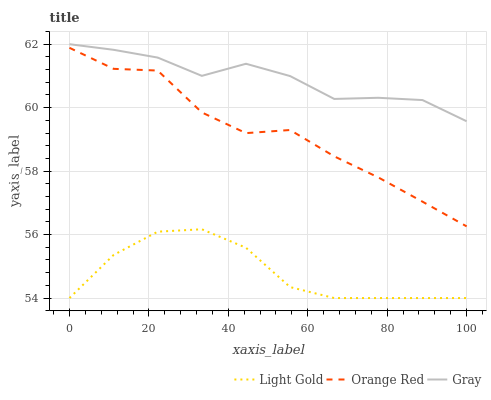Does Light Gold have the minimum area under the curve?
Answer yes or no. Yes. Does Gray have the maximum area under the curve?
Answer yes or no. Yes. Does Orange Red have the minimum area under the curve?
Answer yes or no. No. Does Orange Red have the maximum area under the curve?
Answer yes or no. No. Is Light Gold the smoothest?
Answer yes or no. Yes. Is Orange Red the roughest?
Answer yes or no. Yes. Is Orange Red the smoothest?
Answer yes or no. No. Is Light Gold the roughest?
Answer yes or no. No. Does Light Gold have the lowest value?
Answer yes or no. Yes. Does Orange Red have the lowest value?
Answer yes or no. No. Does Gray have the highest value?
Answer yes or no. Yes. Does Orange Red have the highest value?
Answer yes or no. No. Is Light Gold less than Gray?
Answer yes or no. Yes. Is Orange Red greater than Light Gold?
Answer yes or no. Yes. Does Light Gold intersect Gray?
Answer yes or no. No. 